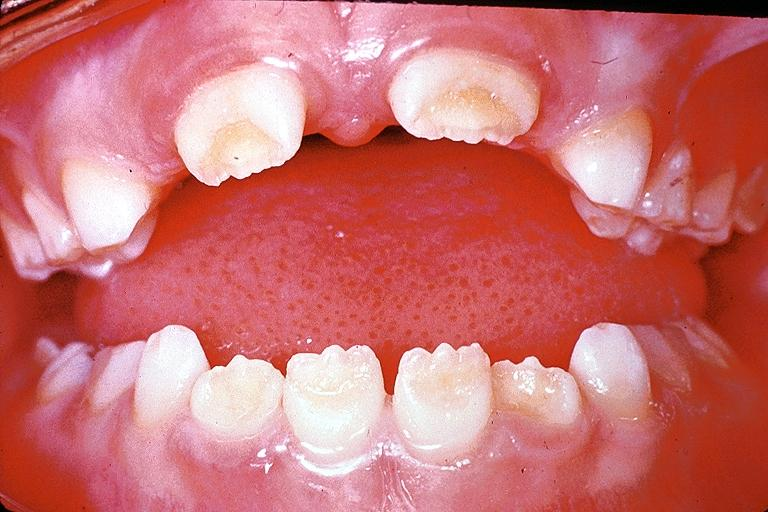s oral present?
Answer the question using a single word or phrase. Yes 